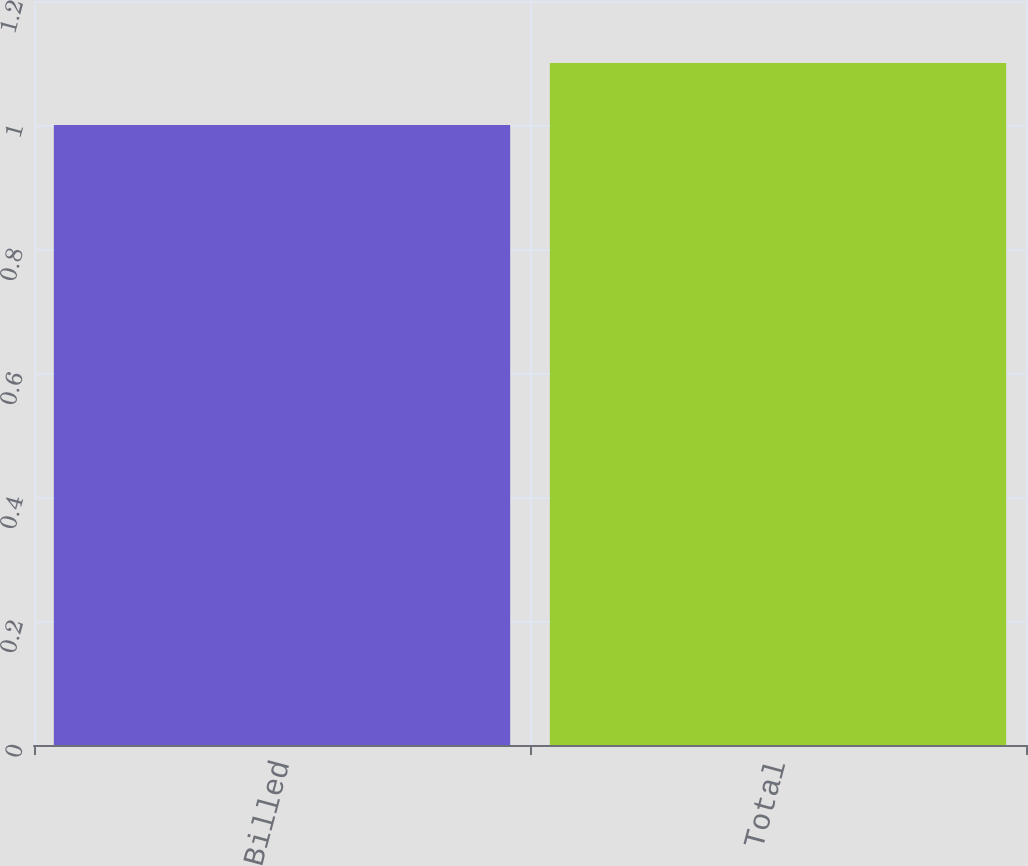Convert chart. <chart><loc_0><loc_0><loc_500><loc_500><bar_chart><fcel>Billed<fcel>Total<nl><fcel>1<fcel>1.1<nl></chart> 